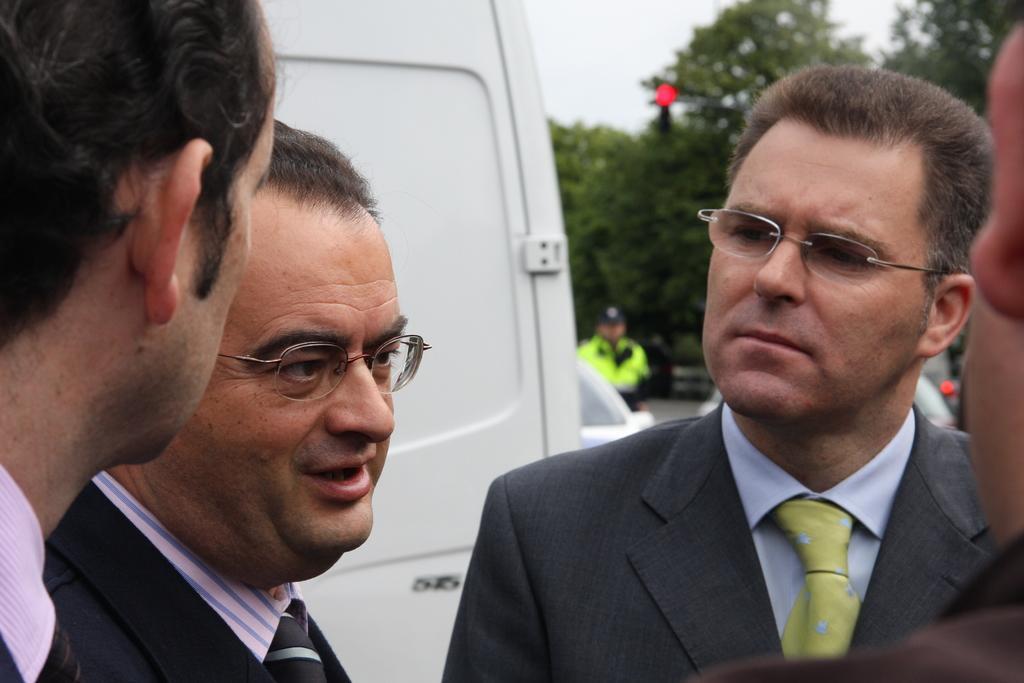Please provide a concise description of this image. In the foreground of this image, there are men standing wearing coats. In the background, there is a vehicle, few trees, a pole and the sky on the top. 